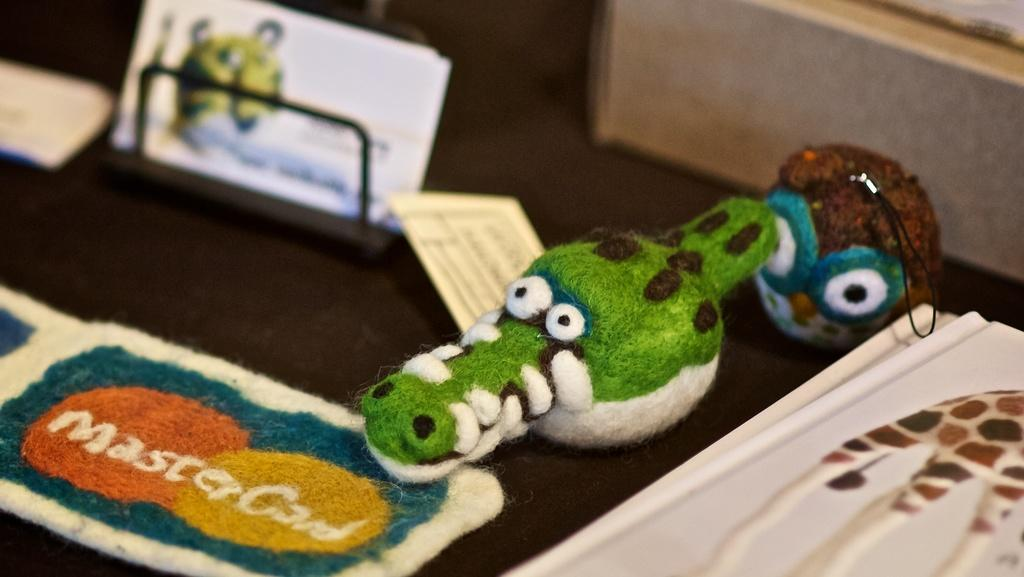What type of items can be seen in the image? There are colorful toys, papers, and a sheet in the image. What might be used for writing or drawing? Papers can be used for writing or drawing. What is covering the surface in the image? There are other objects on a surface in the image. Where is the box located in the image? There is a box in the top right of the image. What is the level of disgust in the image? There is no indication of disgust in the image, as it features colorful toys, papers, a sheet, and a box. What type of brass object can be seen in the image? There is no brass object present in the image. 